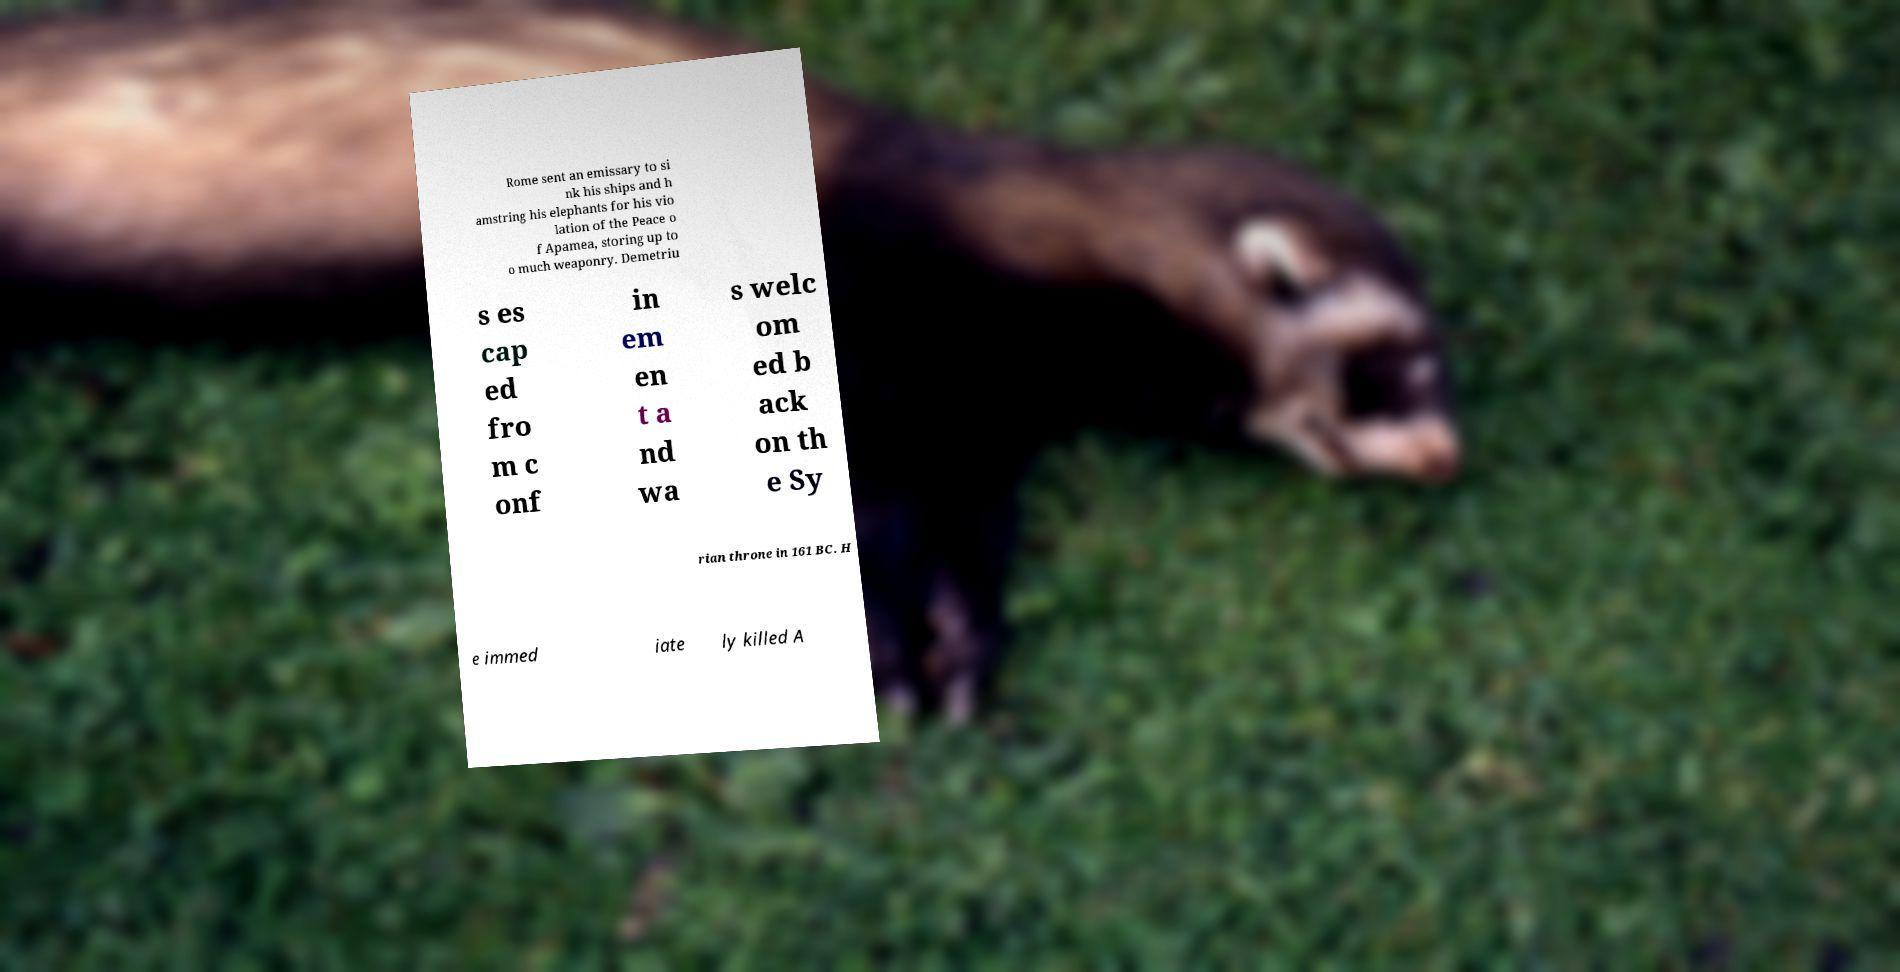I need the written content from this picture converted into text. Can you do that? Rome sent an emissary to si nk his ships and h amstring his elephants for his vio lation of the Peace o f Apamea, storing up to o much weaponry. Demetriu s es cap ed fro m c onf in em en t a nd wa s welc om ed b ack on th e Sy rian throne in 161 BC. H e immed iate ly killed A 